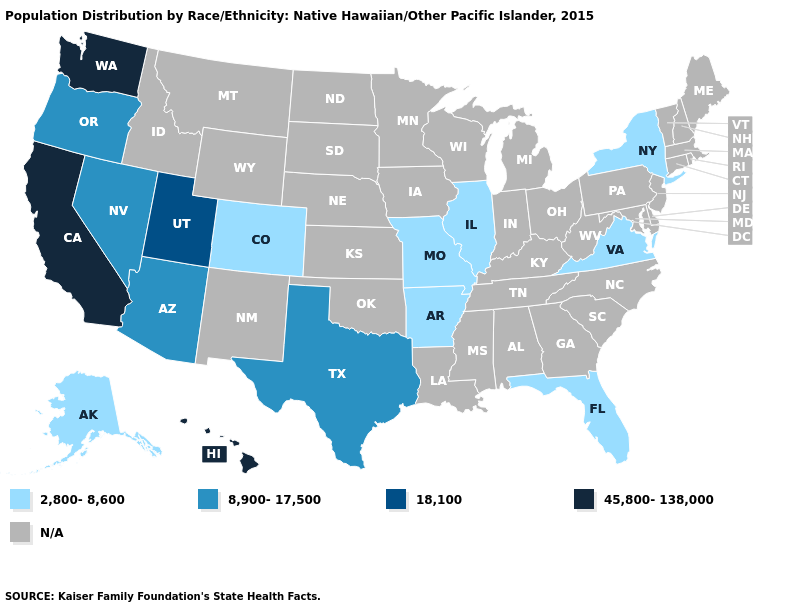Which states have the lowest value in the South?
Be succinct. Arkansas, Florida, Virginia. What is the value of California?
Be succinct. 45,800-138,000. Does New York have the highest value in the USA?
Answer briefly. No. What is the highest value in states that border Oregon?
Keep it brief. 45,800-138,000. Name the states that have a value in the range 45,800-138,000?
Give a very brief answer. California, Hawaii, Washington. What is the value of Ohio?
Keep it brief. N/A. What is the value of Kansas?
Quick response, please. N/A. Does the map have missing data?
Keep it brief. Yes. Does the first symbol in the legend represent the smallest category?
Give a very brief answer. Yes. Does the map have missing data?
Be succinct. Yes. Does Florida have the highest value in the USA?
Give a very brief answer. No. Name the states that have a value in the range 45,800-138,000?
Be succinct. California, Hawaii, Washington. 